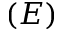Convert formula to latex. <formula><loc_0><loc_0><loc_500><loc_500>( E )</formula> 